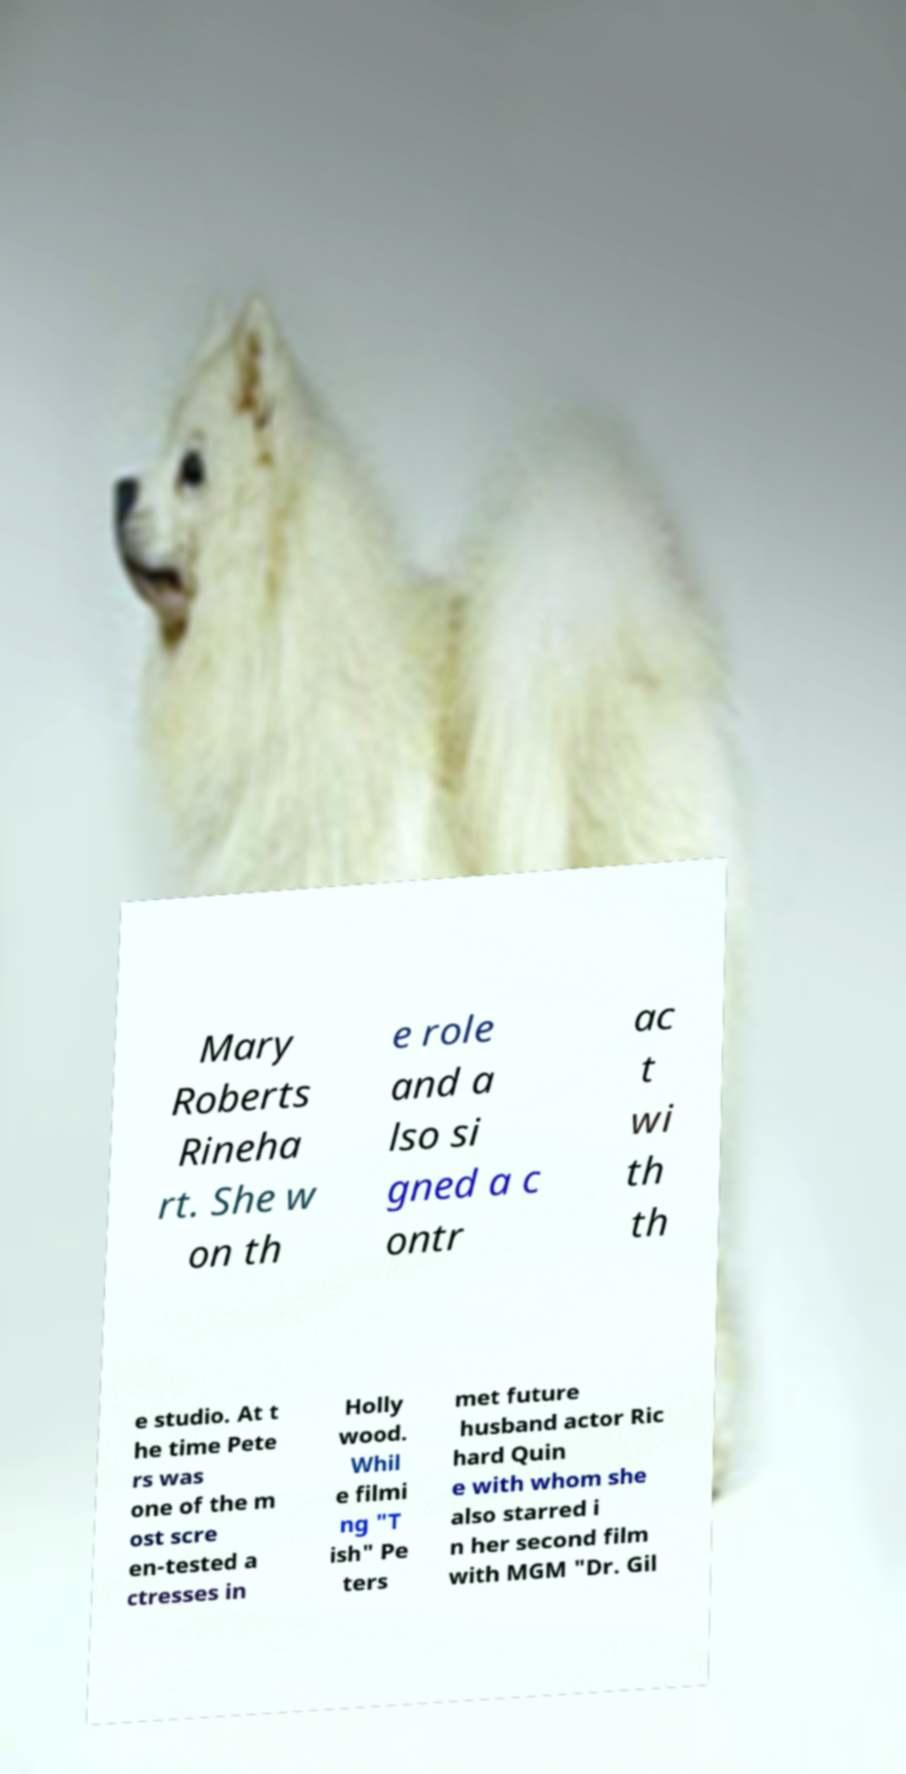I need the written content from this picture converted into text. Can you do that? Mary Roberts Rineha rt. She w on th e role and a lso si gned a c ontr ac t wi th th e studio. At t he time Pete rs was one of the m ost scre en-tested a ctresses in Holly wood. Whil e filmi ng "T ish" Pe ters met future husband actor Ric hard Quin e with whom she also starred i n her second film with MGM "Dr. Gil 